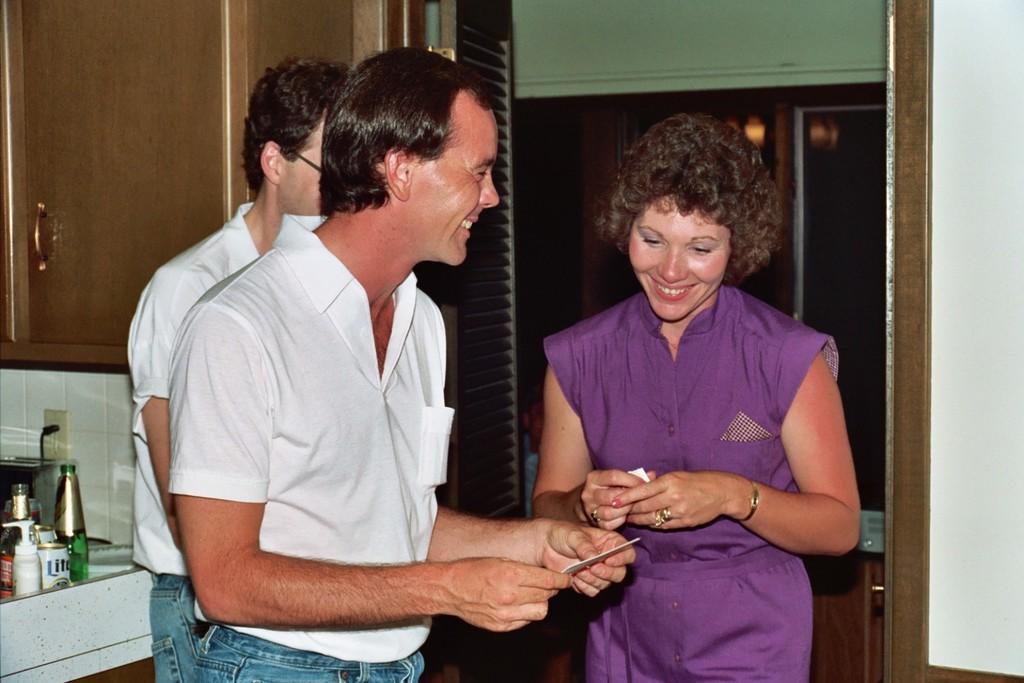Could you give a brief overview of what you see in this image? In this image I can see two men and a woman are standing and smiling. The man and the women are holding some objects in hands. In the background I can see bottles, cupboards and other objects. 